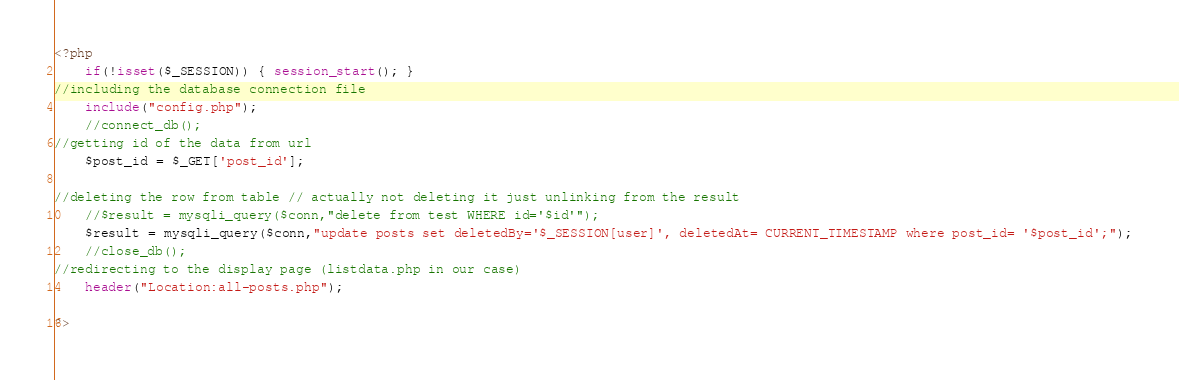Convert code to text. <code><loc_0><loc_0><loc_500><loc_500><_PHP_><?php
    if(!isset($_SESSION)) { session_start(); }
//including the database connection file
    include("config.php");
    //connect_db();
//getting id of the data from url
    $post_id = $_GET['post_id'];

//deleting the row from table // actually not deleting it just unlinking from the result
    //$result = mysqli_query($conn,"delete from test WHERE id='$id'");
    $result = mysqli_query($conn,"update posts set deletedBy='$_SESSION[user]', deletedAt= CURRENT_TIMESTAMP where post_id= '$post_id';");
	//close_db();
//redirecting to the display page (listdata.php in our case)
    header("Location:all-posts.php");

?>

</code> 